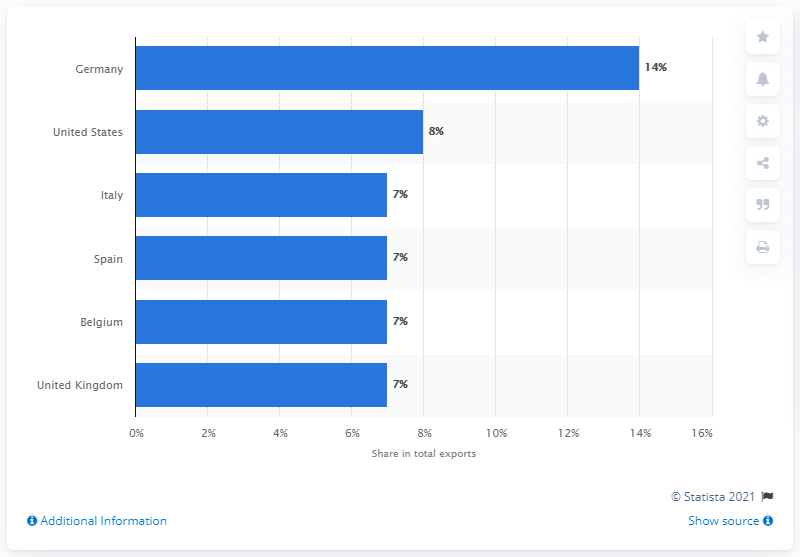Point out several critical features in this image. In 2019, Germany was France's most important export partner. 